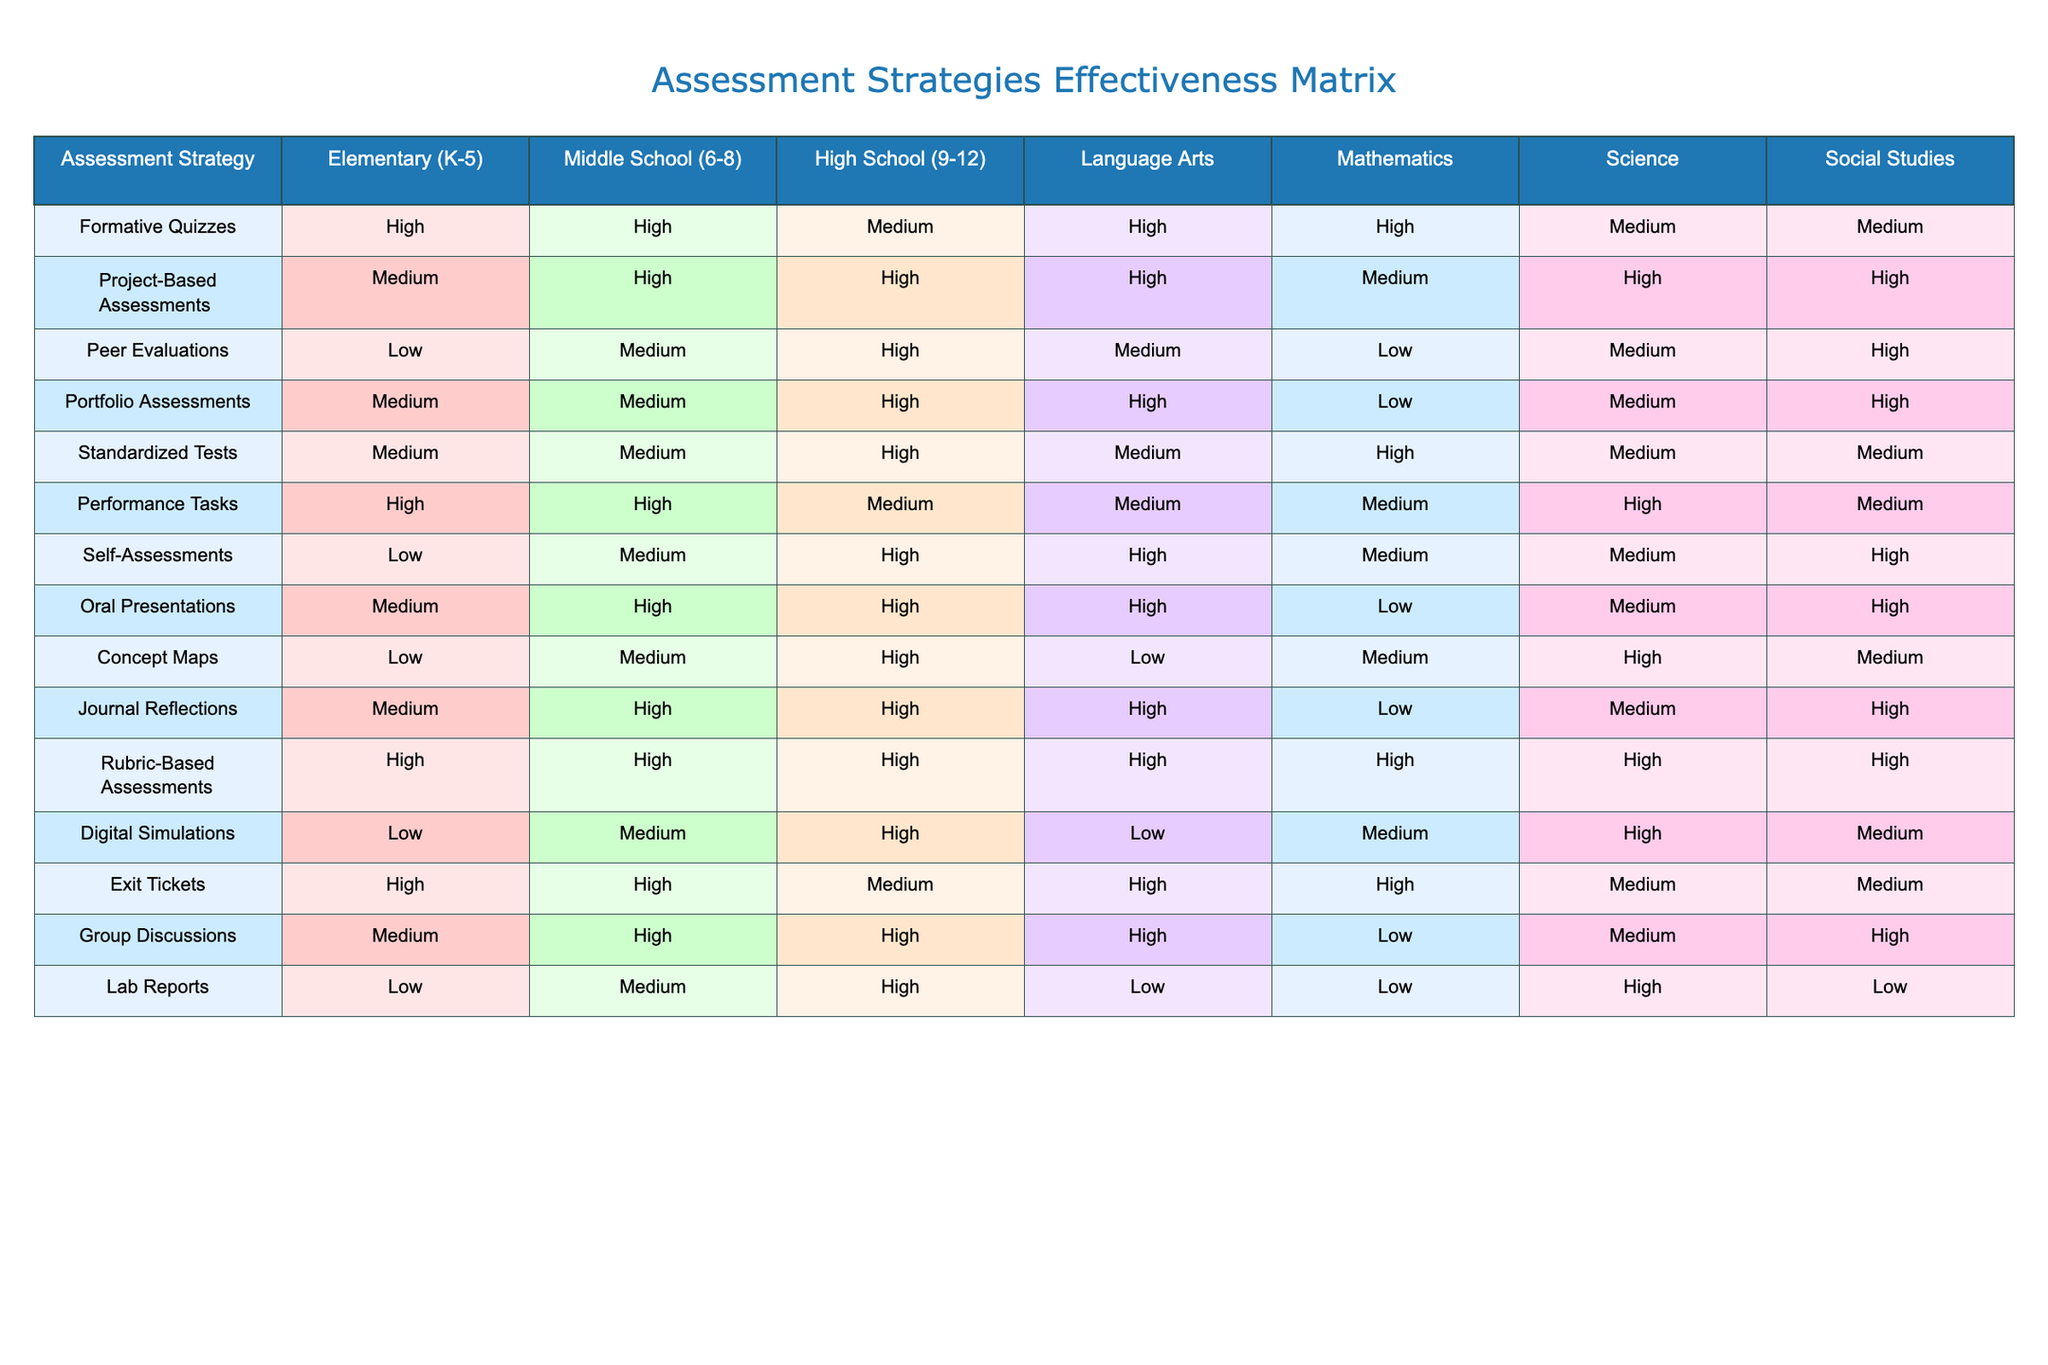What is the effectiveness of Rubric-Based Assessments in High School? The table indicates that Rubric-Based Assessments have a "High" effectiveness rating across all grade levels including High School.
Answer: High Which assessment strategy is rated as the most effective for Middle School Language Arts? In the table, Project-Based Assessments are rated "High" for Middle School Language Arts, making them the most effective strategy in that category.
Answer: Project-Based Assessments For which subject area is Portfolio Assessments rated "Low"? The table shows that Portfolio Assessments are rated "Low" for Mathematics.
Answer: Mathematics What is the average effectiveness rating for Peer Evaluations across all grade levels? The ratings for Peer Evaluations are Low, Medium, and High. Converting them to numerical values (Low=1, Medium=2, High=3): (1 + 2 + 3)/3 gives an average of 2, which corresponds to Medium.
Answer: Medium Is Performance Tasks considered more effective than Standardized Tests in High School? Performance Tasks are rated "Medium," while Standardized Tests are rated "High" for High School, indicating that Standardized Tests are considered more effective.
Answer: No What is the most effective assessment strategy for Social Studies in High School and Middle School? The table indicates that Project-Based Assessments are rated "High" for both High School and Middle School in Social Studies, making it the most effective strategy for that subject.
Answer: Project-Based Assessments Which assessment strategy has the lowest effectiveness rating in Elementary education? The table shows that both Lab Reports and Digital Simulations have a "Low" effectiveness rating in Elementary education.
Answer: Lab Reports and Digital Simulations How do the effectiveness ratings for Exit Tickets compare between Elementary and Middle School? In the table, Exit Tickets are rated "High" for both Elementary and Middle School, showing that they have the same effectiveness rating.
Answer: They are the same: High What is the effectiveness rating for Oral Presentations in High School compared to Middle School? The table displays that Oral Presentations are rated "High" in both Middle School and High School, indicating that they have the same rating in these grade levels.
Answer: They are the same: High Which grade levels show "Medium" effectiveness for Digital Simulations? The table indicates that Digital Simulations have a "Medium" effectiveness rating in Middle School only, while being rated "Low" for Elementary and "High" for High School.
Answer: Middle School 